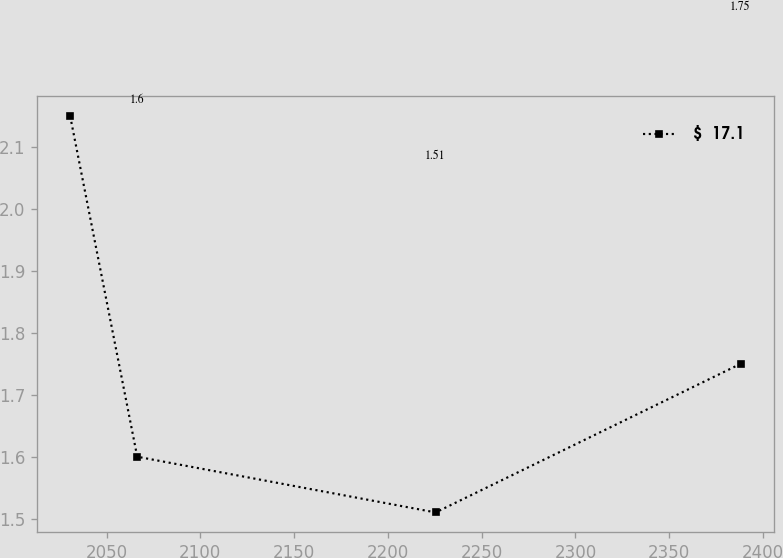Convert chart. <chart><loc_0><loc_0><loc_500><loc_500><line_chart><ecel><fcel>$  17.1<nl><fcel>2030.64<fcel>2.15<nl><fcel>2066.38<fcel>1.6<nl><fcel>2225.48<fcel>1.51<nl><fcel>2388.05<fcel>1.75<nl></chart> 